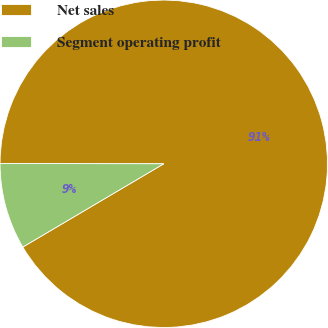Convert chart. <chart><loc_0><loc_0><loc_500><loc_500><pie_chart><fcel>Net sales<fcel>Segment operating profit<nl><fcel>91.48%<fcel>8.52%<nl></chart> 